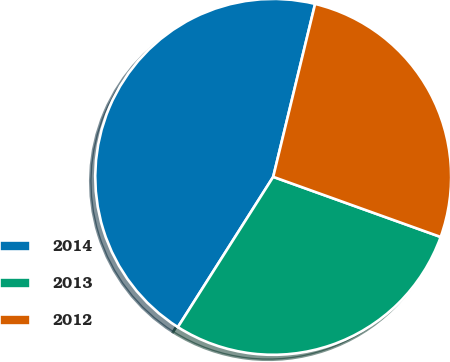Convert chart. <chart><loc_0><loc_0><loc_500><loc_500><pie_chart><fcel>2014<fcel>2013<fcel>2012<nl><fcel>44.78%<fcel>28.51%<fcel>26.7%<nl></chart> 